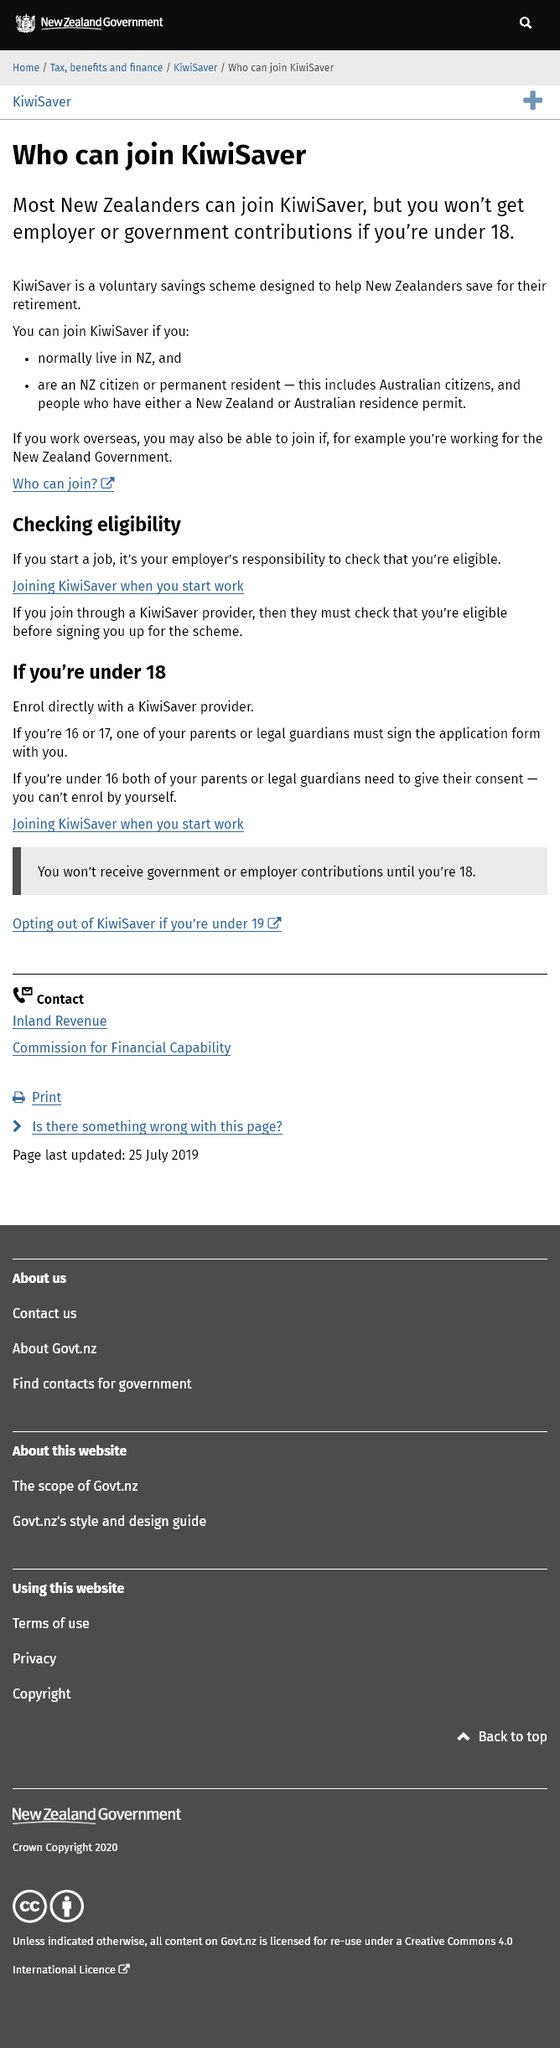Indicate a few pertinent items in this graphic. If you are under the age of 18, you will not be eligible to receive employer or government contributions for your retirement savings. The program that most New Zealanders can sign up for is designed to assist them in saving for their retirement. Yes, those who normally reside in New Zealand can join KiwiSaver. 